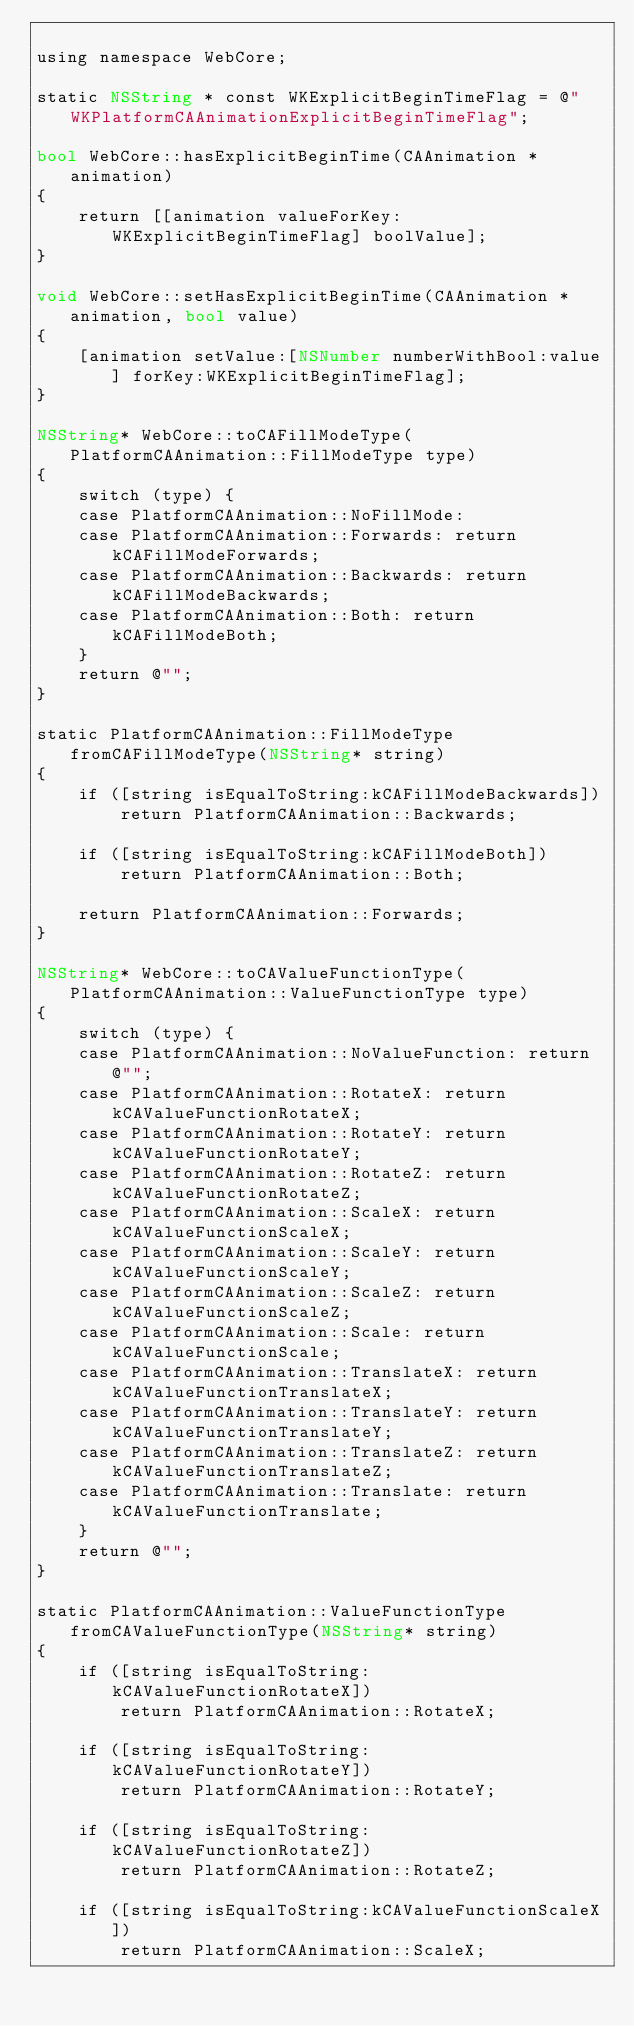Convert code to text. <code><loc_0><loc_0><loc_500><loc_500><_ObjectiveC_>
using namespace WebCore;

static NSString * const WKExplicitBeginTimeFlag = @"WKPlatformCAAnimationExplicitBeginTimeFlag";

bool WebCore::hasExplicitBeginTime(CAAnimation *animation)
{
    return [[animation valueForKey:WKExplicitBeginTimeFlag] boolValue];
}

void WebCore::setHasExplicitBeginTime(CAAnimation *animation, bool value)
{
    [animation setValue:[NSNumber numberWithBool:value] forKey:WKExplicitBeginTimeFlag];
}
    
NSString* WebCore::toCAFillModeType(PlatformCAAnimation::FillModeType type)
{
    switch (type) {
    case PlatformCAAnimation::NoFillMode:
    case PlatformCAAnimation::Forwards: return kCAFillModeForwards;
    case PlatformCAAnimation::Backwards: return kCAFillModeBackwards;
    case PlatformCAAnimation::Both: return kCAFillModeBoth;
    }
    return @"";
}

static PlatformCAAnimation::FillModeType fromCAFillModeType(NSString* string)
{
    if ([string isEqualToString:kCAFillModeBackwards])
        return PlatformCAAnimation::Backwards;

    if ([string isEqualToString:kCAFillModeBoth])
        return PlatformCAAnimation::Both;

    return PlatformCAAnimation::Forwards;
}

NSString* WebCore::toCAValueFunctionType(PlatformCAAnimation::ValueFunctionType type)
{
    switch (type) {
    case PlatformCAAnimation::NoValueFunction: return @"";
    case PlatformCAAnimation::RotateX: return kCAValueFunctionRotateX;
    case PlatformCAAnimation::RotateY: return kCAValueFunctionRotateY;
    case PlatformCAAnimation::RotateZ: return kCAValueFunctionRotateZ;
    case PlatformCAAnimation::ScaleX: return kCAValueFunctionScaleX;
    case PlatformCAAnimation::ScaleY: return kCAValueFunctionScaleY;
    case PlatformCAAnimation::ScaleZ: return kCAValueFunctionScaleZ;
    case PlatformCAAnimation::Scale: return kCAValueFunctionScale;
    case PlatformCAAnimation::TranslateX: return kCAValueFunctionTranslateX;
    case PlatformCAAnimation::TranslateY: return kCAValueFunctionTranslateY;
    case PlatformCAAnimation::TranslateZ: return kCAValueFunctionTranslateZ;
    case PlatformCAAnimation::Translate: return kCAValueFunctionTranslate;
    }
    return @"";
}

static PlatformCAAnimation::ValueFunctionType fromCAValueFunctionType(NSString* string)
{
    if ([string isEqualToString:kCAValueFunctionRotateX])
        return PlatformCAAnimation::RotateX;

    if ([string isEqualToString:kCAValueFunctionRotateY])
        return PlatformCAAnimation::RotateY;

    if ([string isEqualToString:kCAValueFunctionRotateZ])
        return PlatformCAAnimation::RotateZ;

    if ([string isEqualToString:kCAValueFunctionScaleX])
        return PlatformCAAnimation::ScaleX;
</code> 